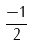Convert formula to latex. <formula><loc_0><loc_0><loc_500><loc_500>\frac { - 1 } { 2 }</formula> 